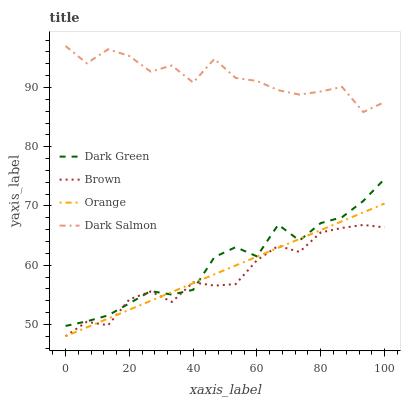Does Brown have the minimum area under the curve?
Answer yes or no. Yes. Does Dark Salmon have the maximum area under the curve?
Answer yes or no. Yes. Does Dark Salmon have the minimum area under the curve?
Answer yes or no. No. Does Brown have the maximum area under the curve?
Answer yes or no. No. Is Orange the smoothest?
Answer yes or no. Yes. Is Dark Salmon the roughest?
Answer yes or no. Yes. Is Brown the smoothest?
Answer yes or no. No. Is Brown the roughest?
Answer yes or no. No. Does Dark Salmon have the lowest value?
Answer yes or no. No. Does Dark Salmon have the highest value?
Answer yes or no. Yes. Does Brown have the highest value?
Answer yes or no. No. Is Dark Green less than Dark Salmon?
Answer yes or no. Yes. Is Dark Salmon greater than Orange?
Answer yes or no. Yes. Does Orange intersect Dark Green?
Answer yes or no. Yes. Is Orange less than Dark Green?
Answer yes or no. No. Is Orange greater than Dark Green?
Answer yes or no. No. Does Dark Green intersect Dark Salmon?
Answer yes or no. No. 